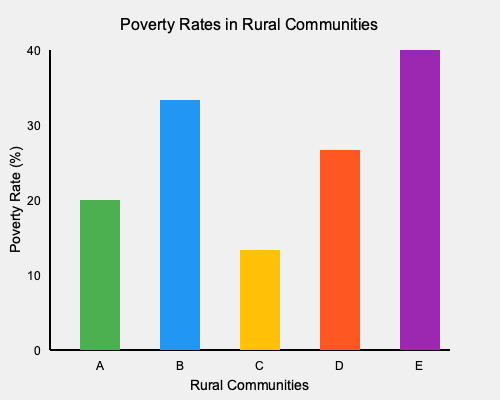Based on the bar graph showing poverty rates in rural communities A through E, which community has the second-highest poverty rate, and what is the approximate difference in percentage points between the highest and lowest poverty rates? To answer this question, we need to follow these steps:

1. Identify the poverty rates for each community:
   Community A: ~15%
   Community B: ~25%
   Community C: ~10%
   Community D: ~20%
   Community E: ~30%

2. Rank the communities from highest to lowest poverty rate:
   E (30%) > B (25%) > D (20%) > A (15%) > C (10%)

3. Identify the community with the second-highest poverty rate:
   Community B with ~25%

4. Calculate the difference between the highest and lowest poverty rates:
   Highest (Community E): ~30%
   Lowest (Community C): ~10%
   Difference: 30% - 10% = 20 percentage points

Therefore, the community with the second-highest poverty rate is B, and the approximate difference between the highest and lowest poverty rates is 20 percentage points.
Answer: Community B; 20 percentage points 